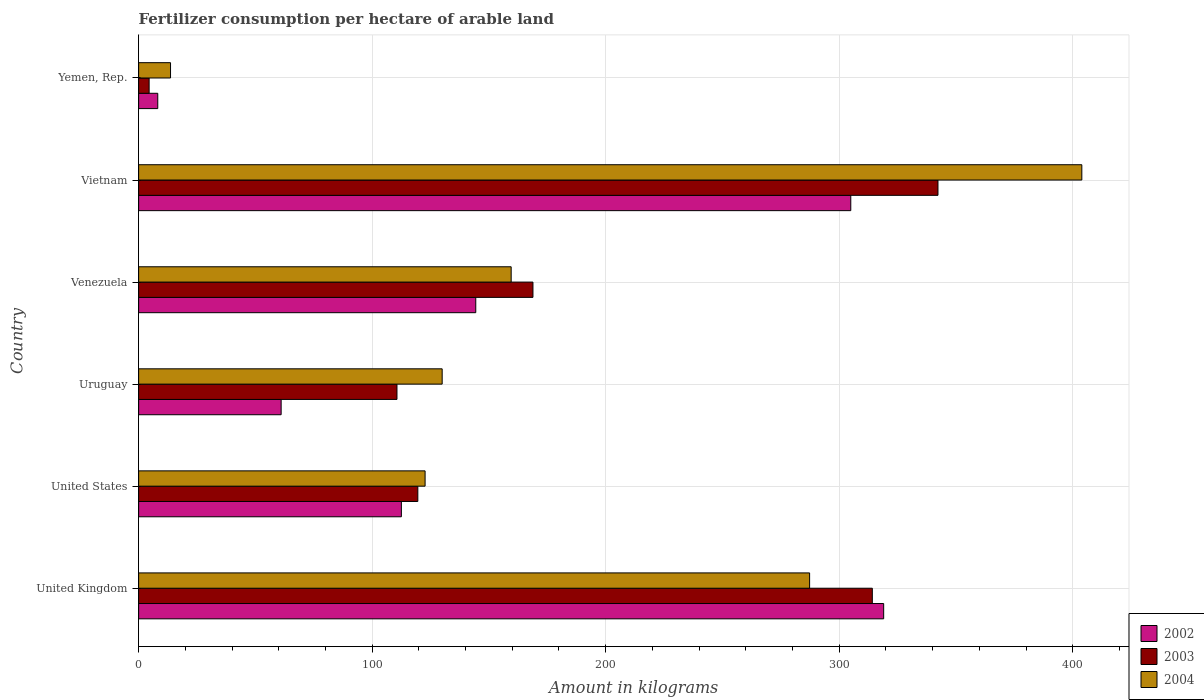Are the number of bars per tick equal to the number of legend labels?
Keep it short and to the point. Yes. How many bars are there on the 5th tick from the top?
Provide a succinct answer. 3. How many bars are there on the 4th tick from the bottom?
Offer a very short reply. 3. What is the label of the 3rd group of bars from the top?
Provide a short and direct response. Venezuela. In how many cases, is the number of bars for a given country not equal to the number of legend labels?
Ensure brevity in your answer.  0. What is the amount of fertilizer consumption in 2004 in Venezuela?
Offer a terse response. 159.53. Across all countries, what is the maximum amount of fertilizer consumption in 2004?
Your answer should be compact. 403.91. Across all countries, what is the minimum amount of fertilizer consumption in 2002?
Make the answer very short. 8.2. In which country was the amount of fertilizer consumption in 2004 maximum?
Make the answer very short. Vietnam. In which country was the amount of fertilizer consumption in 2003 minimum?
Provide a succinct answer. Yemen, Rep. What is the total amount of fertilizer consumption in 2004 in the graph?
Provide a short and direct response. 1117.1. What is the difference between the amount of fertilizer consumption in 2002 in United Kingdom and that in Uruguay?
Your answer should be compact. 258.02. What is the difference between the amount of fertilizer consumption in 2002 in Venezuela and the amount of fertilizer consumption in 2003 in Uruguay?
Your answer should be compact. 33.74. What is the average amount of fertilizer consumption in 2002 per country?
Your response must be concise. 158.35. What is the difference between the amount of fertilizer consumption in 2003 and amount of fertilizer consumption in 2004 in Yemen, Rep.?
Offer a terse response. -9.17. In how many countries, is the amount of fertilizer consumption in 2002 greater than 100 kg?
Ensure brevity in your answer.  4. What is the ratio of the amount of fertilizer consumption in 2002 in Venezuela to that in Yemen, Rep.?
Offer a very short reply. 17.61. Is the difference between the amount of fertilizer consumption in 2003 in Venezuela and Vietnam greater than the difference between the amount of fertilizer consumption in 2004 in Venezuela and Vietnam?
Offer a terse response. Yes. What is the difference between the highest and the second highest amount of fertilizer consumption in 2002?
Your response must be concise. 14.09. What is the difference between the highest and the lowest amount of fertilizer consumption in 2002?
Your answer should be compact. 310.85. In how many countries, is the amount of fertilizer consumption in 2004 greater than the average amount of fertilizer consumption in 2004 taken over all countries?
Ensure brevity in your answer.  2. What does the 1st bar from the bottom in Yemen, Rep. represents?
Offer a terse response. 2002. How many bars are there?
Provide a succinct answer. 18. How many countries are there in the graph?
Ensure brevity in your answer.  6. Are the values on the major ticks of X-axis written in scientific E-notation?
Offer a terse response. No. How are the legend labels stacked?
Provide a succinct answer. Vertical. What is the title of the graph?
Keep it short and to the point. Fertilizer consumption per hectare of arable land. What is the label or title of the X-axis?
Your answer should be compact. Amount in kilograms. What is the label or title of the Y-axis?
Your response must be concise. Country. What is the Amount in kilograms of 2002 in United Kingdom?
Ensure brevity in your answer.  319.05. What is the Amount in kilograms in 2003 in United Kingdom?
Offer a very short reply. 314.19. What is the Amount in kilograms in 2004 in United Kingdom?
Keep it short and to the point. 287.33. What is the Amount in kilograms in 2002 in United States?
Your answer should be compact. 112.52. What is the Amount in kilograms of 2003 in United States?
Ensure brevity in your answer.  119.56. What is the Amount in kilograms in 2004 in United States?
Make the answer very short. 122.67. What is the Amount in kilograms in 2002 in Uruguay?
Give a very brief answer. 61.03. What is the Amount in kilograms in 2003 in Uruguay?
Offer a very short reply. 110.63. What is the Amount in kilograms in 2004 in Uruguay?
Give a very brief answer. 129.99. What is the Amount in kilograms of 2002 in Venezuela?
Provide a succinct answer. 144.37. What is the Amount in kilograms of 2003 in Venezuela?
Give a very brief answer. 168.86. What is the Amount in kilograms of 2004 in Venezuela?
Provide a short and direct response. 159.53. What is the Amount in kilograms in 2002 in Vietnam?
Your response must be concise. 304.96. What is the Amount in kilograms of 2003 in Vietnam?
Offer a very short reply. 342.3. What is the Amount in kilograms of 2004 in Vietnam?
Make the answer very short. 403.91. What is the Amount in kilograms in 2002 in Yemen, Rep.?
Ensure brevity in your answer.  8.2. What is the Amount in kilograms in 2003 in Yemen, Rep.?
Provide a short and direct response. 4.5. What is the Amount in kilograms of 2004 in Yemen, Rep.?
Offer a very short reply. 13.66. Across all countries, what is the maximum Amount in kilograms in 2002?
Give a very brief answer. 319.05. Across all countries, what is the maximum Amount in kilograms of 2003?
Keep it short and to the point. 342.3. Across all countries, what is the maximum Amount in kilograms of 2004?
Your response must be concise. 403.91. Across all countries, what is the minimum Amount in kilograms of 2002?
Offer a very short reply. 8.2. Across all countries, what is the minimum Amount in kilograms of 2003?
Offer a terse response. 4.5. Across all countries, what is the minimum Amount in kilograms in 2004?
Offer a very short reply. 13.66. What is the total Amount in kilograms of 2002 in the graph?
Provide a short and direct response. 950.13. What is the total Amount in kilograms in 2003 in the graph?
Provide a succinct answer. 1060.04. What is the total Amount in kilograms of 2004 in the graph?
Your answer should be very brief. 1117.1. What is the difference between the Amount in kilograms of 2002 in United Kingdom and that in United States?
Provide a succinct answer. 206.53. What is the difference between the Amount in kilograms of 2003 in United Kingdom and that in United States?
Your answer should be compact. 194.63. What is the difference between the Amount in kilograms in 2004 in United Kingdom and that in United States?
Keep it short and to the point. 164.66. What is the difference between the Amount in kilograms of 2002 in United Kingdom and that in Uruguay?
Provide a succinct answer. 258.02. What is the difference between the Amount in kilograms in 2003 in United Kingdom and that in Uruguay?
Your answer should be compact. 203.56. What is the difference between the Amount in kilograms in 2004 in United Kingdom and that in Uruguay?
Your answer should be compact. 157.35. What is the difference between the Amount in kilograms in 2002 in United Kingdom and that in Venezuela?
Give a very brief answer. 174.68. What is the difference between the Amount in kilograms of 2003 in United Kingdom and that in Venezuela?
Ensure brevity in your answer.  145.33. What is the difference between the Amount in kilograms in 2004 in United Kingdom and that in Venezuela?
Your response must be concise. 127.8. What is the difference between the Amount in kilograms in 2002 in United Kingdom and that in Vietnam?
Your answer should be compact. 14.09. What is the difference between the Amount in kilograms of 2003 in United Kingdom and that in Vietnam?
Provide a short and direct response. -28.11. What is the difference between the Amount in kilograms in 2004 in United Kingdom and that in Vietnam?
Your response must be concise. -116.57. What is the difference between the Amount in kilograms of 2002 in United Kingdom and that in Yemen, Rep.?
Your response must be concise. 310.85. What is the difference between the Amount in kilograms of 2003 in United Kingdom and that in Yemen, Rep.?
Your answer should be very brief. 309.69. What is the difference between the Amount in kilograms in 2004 in United Kingdom and that in Yemen, Rep.?
Ensure brevity in your answer.  273.67. What is the difference between the Amount in kilograms in 2002 in United States and that in Uruguay?
Your response must be concise. 51.49. What is the difference between the Amount in kilograms in 2003 in United States and that in Uruguay?
Give a very brief answer. 8.93. What is the difference between the Amount in kilograms in 2004 in United States and that in Uruguay?
Offer a very short reply. -7.32. What is the difference between the Amount in kilograms of 2002 in United States and that in Venezuela?
Your response must be concise. -31.85. What is the difference between the Amount in kilograms in 2003 in United States and that in Venezuela?
Offer a terse response. -49.3. What is the difference between the Amount in kilograms in 2004 in United States and that in Venezuela?
Keep it short and to the point. -36.86. What is the difference between the Amount in kilograms in 2002 in United States and that in Vietnam?
Offer a terse response. -192.45. What is the difference between the Amount in kilograms in 2003 in United States and that in Vietnam?
Keep it short and to the point. -222.74. What is the difference between the Amount in kilograms in 2004 in United States and that in Vietnam?
Make the answer very short. -281.24. What is the difference between the Amount in kilograms in 2002 in United States and that in Yemen, Rep.?
Give a very brief answer. 104.32. What is the difference between the Amount in kilograms of 2003 in United States and that in Yemen, Rep.?
Keep it short and to the point. 115.06. What is the difference between the Amount in kilograms of 2004 in United States and that in Yemen, Rep.?
Ensure brevity in your answer.  109.01. What is the difference between the Amount in kilograms of 2002 in Uruguay and that in Venezuela?
Make the answer very short. -83.34. What is the difference between the Amount in kilograms in 2003 in Uruguay and that in Venezuela?
Your answer should be compact. -58.23. What is the difference between the Amount in kilograms in 2004 in Uruguay and that in Venezuela?
Your response must be concise. -29.55. What is the difference between the Amount in kilograms in 2002 in Uruguay and that in Vietnam?
Your answer should be compact. -243.94. What is the difference between the Amount in kilograms of 2003 in Uruguay and that in Vietnam?
Your answer should be compact. -231.67. What is the difference between the Amount in kilograms in 2004 in Uruguay and that in Vietnam?
Give a very brief answer. -273.92. What is the difference between the Amount in kilograms of 2002 in Uruguay and that in Yemen, Rep.?
Ensure brevity in your answer.  52.83. What is the difference between the Amount in kilograms in 2003 in Uruguay and that in Yemen, Rep.?
Give a very brief answer. 106.13. What is the difference between the Amount in kilograms of 2004 in Uruguay and that in Yemen, Rep.?
Ensure brevity in your answer.  116.32. What is the difference between the Amount in kilograms in 2002 in Venezuela and that in Vietnam?
Keep it short and to the point. -160.59. What is the difference between the Amount in kilograms in 2003 in Venezuela and that in Vietnam?
Provide a short and direct response. -173.44. What is the difference between the Amount in kilograms in 2004 in Venezuela and that in Vietnam?
Ensure brevity in your answer.  -244.37. What is the difference between the Amount in kilograms in 2002 in Venezuela and that in Yemen, Rep.?
Ensure brevity in your answer.  136.17. What is the difference between the Amount in kilograms of 2003 in Venezuela and that in Yemen, Rep.?
Provide a short and direct response. 164.36. What is the difference between the Amount in kilograms in 2004 in Venezuela and that in Yemen, Rep.?
Make the answer very short. 145.87. What is the difference between the Amount in kilograms of 2002 in Vietnam and that in Yemen, Rep.?
Offer a very short reply. 296.77. What is the difference between the Amount in kilograms of 2003 in Vietnam and that in Yemen, Rep.?
Offer a very short reply. 337.81. What is the difference between the Amount in kilograms of 2004 in Vietnam and that in Yemen, Rep.?
Your answer should be very brief. 390.24. What is the difference between the Amount in kilograms in 2002 in United Kingdom and the Amount in kilograms in 2003 in United States?
Ensure brevity in your answer.  199.49. What is the difference between the Amount in kilograms of 2002 in United Kingdom and the Amount in kilograms of 2004 in United States?
Offer a very short reply. 196.38. What is the difference between the Amount in kilograms of 2003 in United Kingdom and the Amount in kilograms of 2004 in United States?
Give a very brief answer. 191.52. What is the difference between the Amount in kilograms of 2002 in United Kingdom and the Amount in kilograms of 2003 in Uruguay?
Give a very brief answer. 208.42. What is the difference between the Amount in kilograms in 2002 in United Kingdom and the Amount in kilograms in 2004 in Uruguay?
Keep it short and to the point. 189.06. What is the difference between the Amount in kilograms in 2003 in United Kingdom and the Amount in kilograms in 2004 in Uruguay?
Your answer should be very brief. 184.2. What is the difference between the Amount in kilograms in 2002 in United Kingdom and the Amount in kilograms in 2003 in Venezuela?
Keep it short and to the point. 150.19. What is the difference between the Amount in kilograms of 2002 in United Kingdom and the Amount in kilograms of 2004 in Venezuela?
Your response must be concise. 159.52. What is the difference between the Amount in kilograms of 2003 in United Kingdom and the Amount in kilograms of 2004 in Venezuela?
Make the answer very short. 154.66. What is the difference between the Amount in kilograms of 2002 in United Kingdom and the Amount in kilograms of 2003 in Vietnam?
Provide a short and direct response. -23.25. What is the difference between the Amount in kilograms of 2002 in United Kingdom and the Amount in kilograms of 2004 in Vietnam?
Offer a terse response. -84.86. What is the difference between the Amount in kilograms of 2003 in United Kingdom and the Amount in kilograms of 2004 in Vietnam?
Provide a short and direct response. -89.72. What is the difference between the Amount in kilograms of 2002 in United Kingdom and the Amount in kilograms of 2003 in Yemen, Rep.?
Offer a very short reply. 314.55. What is the difference between the Amount in kilograms in 2002 in United Kingdom and the Amount in kilograms in 2004 in Yemen, Rep.?
Make the answer very short. 305.39. What is the difference between the Amount in kilograms of 2003 in United Kingdom and the Amount in kilograms of 2004 in Yemen, Rep.?
Keep it short and to the point. 300.53. What is the difference between the Amount in kilograms of 2002 in United States and the Amount in kilograms of 2003 in Uruguay?
Ensure brevity in your answer.  1.89. What is the difference between the Amount in kilograms of 2002 in United States and the Amount in kilograms of 2004 in Uruguay?
Provide a succinct answer. -17.47. What is the difference between the Amount in kilograms in 2003 in United States and the Amount in kilograms in 2004 in Uruguay?
Offer a very short reply. -10.43. What is the difference between the Amount in kilograms in 2002 in United States and the Amount in kilograms in 2003 in Venezuela?
Make the answer very short. -56.34. What is the difference between the Amount in kilograms in 2002 in United States and the Amount in kilograms in 2004 in Venezuela?
Provide a short and direct response. -47.02. What is the difference between the Amount in kilograms of 2003 in United States and the Amount in kilograms of 2004 in Venezuela?
Your response must be concise. -39.97. What is the difference between the Amount in kilograms in 2002 in United States and the Amount in kilograms in 2003 in Vietnam?
Offer a terse response. -229.79. What is the difference between the Amount in kilograms of 2002 in United States and the Amount in kilograms of 2004 in Vietnam?
Offer a very short reply. -291.39. What is the difference between the Amount in kilograms in 2003 in United States and the Amount in kilograms in 2004 in Vietnam?
Ensure brevity in your answer.  -284.35. What is the difference between the Amount in kilograms of 2002 in United States and the Amount in kilograms of 2003 in Yemen, Rep.?
Offer a very short reply. 108.02. What is the difference between the Amount in kilograms of 2002 in United States and the Amount in kilograms of 2004 in Yemen, Rep.?
Your answer should be compact. 98.85. What is the difference between the Amount in kilograms of 2003 in United States and the Amount in kilograms of 2004 in Yemen, Rep.?
Your answer should be compact. 105.9. What is the difference between the Amount in kilograms in 2002 in Uruguay and the Amount in kilograms in 2003 in Venezuela?
Ensure brevity in your answer.  -107.83. What is the difference between the Amount in kilograms of 2002 in Uruguay and the Amount in kilograms of 2004 in Venezuela?
Your answer should be compact. -98.51. What is the difference between the Amount in kilograms in 2003 in Uruguay and the Amount in kilograms in 2004 in Venezuela?
Keep it short and to the point. -48.9. What is the difference between the Amount in kilograms of 2002 in Uruguay and the Amount in kilograms of 2003 in Vietnam?
Your response must be concise. -281.28. What is the difference between the Amount in kilograms in 2002 in Uruguay and the Amount in kilograms in 2004 in Vietnam?
Your answer should be compact. -342.88. What is the difference between the Amount in kilograms in 2003 in Uruguay and the Amount in kilograms in 2004 in Vietnam?
Ensure brevity in your answer.  -293.28. What is the difference between the Amount in kilograms of 2002 in Uruguay and the Amount in kilograms of 2003 in Yemen, Rep.?
Your answer should be very brief. 56.53. What is the difference between the Amount in kilograms in 2002 in Uruguay and the Amount in kilograms in 2004 in Yemen, Rep.?
Your answer should be very brief. 47.36. What is the difference between the Amount in kilograms in 2003 in Uruguay and the Amount in kilograms in 2004 in Yemen, Rep.?
Your answer should be very brief. 96.97. What is the difference between the Amount in kilograms in 2002 in Venezuela and the Amount in kilograms in 2003 in Vietnam?
Offer a very short reply. -197.93. What is the difference between the Amount in kilograms of 2002 in Venezuela and the Amount in kilograms of 2004 in Vietnam?
Offer a very short reply. -259.54. What is the difference between the Amount in kilograms of 2003 in Venezuela and the Amount in kilograms of 2004 in Vietnam?
Your response must be concise. -235.05. What is the difference between the Amount in kilograms of 2002 in Venezuela and the Amount in kilograms of 2003 in Yemen, Rep.?
Give a very brief answer. 139.87. What is the difference between the Amount in kilograms of 2002 in Venezuela and the Amount in kilograms of 2004 in Yemen, Rep.?
Offer a terse response. 130.71. What is the difference between the Amount in kilograms of 2003 in Venezuela and the Amount in kilograms of 2004 in Yemen, Rep.?
Offer a terse response. 155.2. What is the difference between the Amount in kilograms in 2002 in Vietnam and the Amount in kilograms in 2003 in Yemen, Rep.?
Give a very brief answer. 300.47. What is the difference between the Amount in kilograms of 2002 in Vietnam and the Amount in kilograms of 2004 in Yemen, Rep.?
Offer a very short reply. 291.3. What is the difference between the Amount in kilograms of 2003 in Vietnam and the Amount in kilograms of 2004 in Yemen, Rep.?
Offer a very short reply. 328.64. What is the average Amount in kilograms in 2002 per country?
Ensure brevity in your answer.  158.35. What is the average Amount in kilograms of 2003 per country?
Your answer should be compact. 176.67. What is the average Amount in kilograms in 2004 per country?
Keep it short and to the point. 186.18. What is the difference between the Amount in kilograms of 2002 and Amount in kilograms of 2003 in United Kingdom?
Make the answer very short. 4.86. What is the difference between the Amount in kilograms of 2002 and Amount in kilograms of 2004 in United Kingdom?
Offer a terse response. 31.72. What is the difference between the Amount in kilograms in 2003 and Amount in kilograms in 2004 in United Kingdom?
Provide a succinct answer. 26.86. What is the difference between the Amount in kilograms of 2002 and Amount in kilograms of 2003 in United States?
Your answer should be very brief. -7.04. What is the difference between the Amount in kilograms of 2002 and Amount in kilograms of 2004 in United States?
Keep it short and to the point. -10.15. What is the difference between the Amount in kilograms in 2003 and Amount in kilograms in 2004 in United States?
Offer a very short reply. -3.11. What is the difference between the Amount in kilograms of 2002 and Amount in kilograms of 2003 in Uruguay?
Give a very brief answer. -49.6. What is the difference between the Amount in kilograms of 2002 and Amount in kilograms of 2004 in Uruguay?
Your response must be concise. -68.96. What is the difference between the Amount in kilograms of 2003 and Amount in kilograms of 2004 in Uruguay?
Ensure brevity in your answer.  -19.36. What is the difference between the Amount in kilograms of 2002 and Amount in kilograms of 2003 in Venezuela?
Provide a short and direct response. -24.49. What is the difference between the Amount in kilograms in 2002 and Amount in kilograms in 2004 in Venezuela?
Ensure brevity in your answer.  -15.16. What is the difference between the Amount in kilograms of 2003 and Amount in kilograms of 2004 in Venezuela?
Offer a very short reply. 9.33. What is the difference between the Amount in kilograms of 2002 and Amount in kilograms of 2003 in Vietnam?
Offer a terse response. -37.34. What is the difference between the Amount in kilograms in 2002 and Amount in kilograms in 2004 in Vietnam?
Give a very brief answer. -98.94. What is the difference between the Amount in kilograms in 2003 and Amount in kilograms in 2004 in Vietnam?
Give a very brief answer. -61.6. What is the difference between the Amount in kilograms in 2002 and Amount in kilograms in 2003 in Yemen, Rep.?
Offer a very short reply. 3.7. What is the difference between the Amount in kilograms in 2002 and Amount in kilograms in 2004 in Yemen, Rep.?
Offer a terse response. -5.47. What is the difference between the Amount in kilograms in 2003 and Amount in kilograms in 2004 in Yemen, Rep.?
Ensure brevity in your answer.  -9.17. What is the ratio of the Amount in kilograms of 2002 in United Kingdom to that in United States?
Your answer should be compact. 2.84. What is the ratio of the Amount in kilograms in 2003 in United Kingdom to that in United States?
Offer a very short reply. 2.63. What is the ratio of the Amount in kilograms in 2004 in United Kingdom to that in United States?
Your answer should be compact. 2.34. What is the ratio of the Amount in kilograms of 2002 in United Kingdom to that in Uruguay?
Provide a succinct answer. 5.23. What is the ratio of the Amount in kilograms in 2003 in United Kingdom to that in Uruguay?
Keep it short and to the point. 2.84. What is the ratio of the Amount in kilograms of 2004 in United Kingdom to that in Uruguay?
Give a very brief answer. 2.21. What is the ratio of the Amount in kilograms of 2002 in United Kingdom to that in Venezuela?
Ensure brevity in your answer.  2.21. What is the ratio of the Amount in kilograms of 2003 in United Kingdom to that in Venezuela?
Make the answer very short. 1.86. What is the ratio of the Amount in kilograms in 2004 in United Kingdom to that in Venezuela?
Your response must be concise. 1.8. What is the ratio of the Amount in kilograms in 2002 in United Kingdom to that in Vietnam?
Ensure brevity in your answer.  1.05. What is the ratio of the Amount in kilograms of 2003 in United Kingdom to that in Vietnam?
Offer a terse response. 0.92. What is the ratio of the Amount in kilograms of 2004 in United Kingdom to that in Vietnam?
Offer a very short reply. 0.71. What is the ratio of the Amount in kilograms of 2002 in United Kingdom to that in Yemen, Rep.?
Your response must be concise. 38.92. What is the ratio of the Amount in kilograms of 2003 in United Kingdom to that in Yemen, Rep.?
Offer a very short reply. 69.87. What is the ratio of the Amount in kilograms of 2004 in United Kingdom to that in Yemen, Rep.?
Your answer should be compact. 21.03. What is the ratio of the Amount in kilograms in 2002 in United States to that in Uruguay?
Offer a terse response. 1.84. What is the ratio of the Amount in kilograms of 2003 in United States to that in Uruguay?
Give a very brief answer. 1.08. What is the ratio of the Amount in kilograms in 2004 in United States to that in Uruguay?
Provide a succinct answer. 0.94. What is the ratio of the Amount in kilograms of 2002 in United States to that in Venezuela?
Your answer should be very brief. 0.78. What is the ratio of the Amount in kilograms of 2003 in United States to that in Venezuela?
Your answer should be compact. 0.71. What is the ratio of the Amount in kilograms in 2004 in United States to that in Venezuela?
Provide a short and direct response. 0.77. What is the ratio of the Amount in kilograms in 2002 in United States to that in Vietnam?
Your response must be concise. 0.37. What is the ratio of the Amount in kilograms of 2003 in United States to that in Vietnam?
Ensure brevity in your answer.  0.35. What is the ratio of the Amount in kilograms in 2004 in United States to that in Vietnam?
Ensure brevity in your answer.  0.3. What is the ratio of the Amount in kilograms in 2002 in United States to that in Yemen, Rep.?
Give a very brief answer. 13.73. What is the ratio of the Amount in kilograms in 2003 in United States to that in Yemen, Rep.?
Offer a terse response. 26.59. What is the ratio of the Amount in kilograms in 2004 in United States to that in Yemen, Rep.?
Keep it short and to the point. 8.98. What is the ratio of the Amount in kilograms in 2002 in Uruguay to that in Venezuela?
Your response must be concise. 0.42. What is the ratio of the Amount in kilograms in 2003 in Uruguay to that in Venezuela?
Your answer should be compact. 0.66. What is the ratio of the Amount in kilograms of 2004 in Uruguay to that in Venezuela?
Your answer should be very brief. 0.81. What is the ratio of the Amount in kilograms in 2002 in Uruguay to that in Vietnam?
Provide a succinct answer. 0.2. What is the ratio of the Amount in kilograms of 2003 in Uruguay to that in Vietnam?
Offer a very short reply. 0.32. What is the ratio of the Amount in kilograms of 2004 in Uruguay to that in Vietnam?
Offer a very short reply. 0.32. What is the ratio of the Amount in kilograms of 2002 in Uruguay to that in Yemen, Rep.?
Your response must be concise. 7.44. What is the ratio of the Amount in kilograms in 2003 in Uruguay to that in Yemen, Rep.?
Offer a very short reply. 24.6. What is the ratio of the Amount in kilograms of 2004 in Uruguay to that in Yemen, Rep.?
Make the answer very short. 9.51. What is the ratio of the Amount in kilograms in 2002 in Venezuela to that in Vietnam?
Give a very brief answer. 0.47. What is the ratio of the Amount in kilograms in 2003 in Venezuela to that in Vietnam?
Keep it short and to the point. 0.49. What is the ratio of the Amount in kilograms in 2004 in Venezuela to that in Vietnam?
Your answer should be very brief. 0.4. What is the ratio of the Amount in kilograms in 2002 in Venezuela to that in Yemen, Rep.?
Make the answer very short. 17.61. What is the ratio of the Amount in kilograms of 2003 in Venezuela to that in Yemen, Rep.?
Your answer should be compact. 37.55. What is the ratio of the Amount in kilograms of 2004 in Venezuela to that in Yemen, Rep.?
Provide a short and direct response. 11.68. What is the ratio of the Amount in kilograms of 2002 in Vietnam to that in Yemen, Rep.?
Offer a terse response. 37.2. What is the ratio of the Amount in kilograms of 2003 in Vietnam to that in Yemen, Rep.?
Make the answer very short. 76.12. What is the ratio of the Amount in kilograms of 2004 in Vietnam to that in Yemen, Rep.?
Ensure brevity in your answer.  29.56. What is the difference between the highest and the second highest Amount in kilograms of 2002?
Provide a succinct answer. 14.09. What is the difference between the highest and the second highest Amount in kilograms of 2003?
Your response must be concise. 28.11. What is the difference between the highest and the second highest Amount in kilograms in 2004?
Offer a terse response. 116.57. What is the difference between the highest and the lowest Amount in kilograms of 2002?
Keep it short and to the point. 310.85. What is the difference between the highest and the lowest Amount in kilograms in 2003?
Offer a very short reply. 337.81. What is the difference between the highest and the lowest Amount in kilograms of 2004?
Offer a terse response. 390.24. 